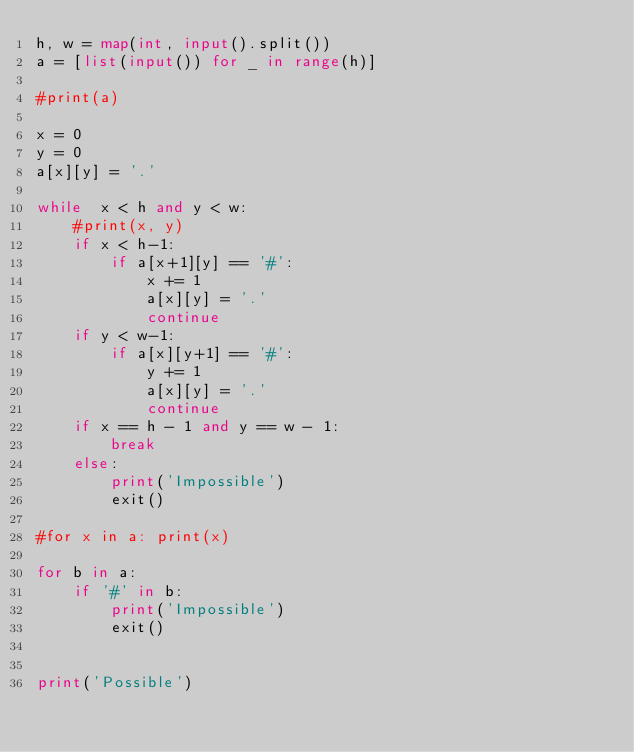Convert code to text. <code><loc_0><loc_0><loc_500><loc_500><_Python_>h, w = map(int, input().split())
a = [list(input()) for _ in range(h)]

#print(a)

x = 0
y = 0
a[x][y] = '.'

while  x < h and y < w:
    #print(x, y)
    if x < h-1:
        if a[x+1][y] == '#':
            x += 1
            a[x][y] = '.'
            continue
    if y < w-1:
        if a[x][y+1] == '#':
            y += 1
            a[x][y] = '.'
            continue
    if x == h - 1 and y == w - 1:
        break
    else:
        print('Impossible')
        exit()

#for x in a: print(x)

for b in a:
    if '#' in b:
        print('Impossible')
        exit()


print('Possible')</code> 